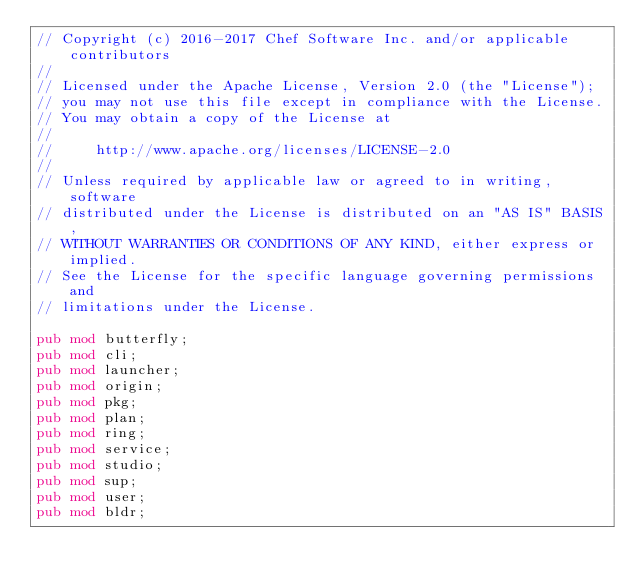Convert code to text. <code><loc_0><loc_0><loc_500><loc_500><_Rust_>// Copyright (c) 2016-2017 Chef Software Inc. and/or applicable contributors
//
// Licensed under the Apache License, Version 2.0 (the "License");
// you may not use this file except in compliance with the License.
// You may obtain a copy of the License at
//
//     http://www.apache.org/licenses/LICENSE-2.0
//
// Unless required by applicable law or agreed to in writing, software
// distributed under the License is distributed on an "AS IS" BASIS,
// WITHOUT WARRANTIES OR CONDITIONS OF ANY KIND, either express or implied.
// See the License for the specific language governing permissions and
// limitations under the License.

pub mod butterfly;
pub mod cli;
pub mod launcher;
pub mod origin;
pub mod pkg;
pub mod plan;
pub mod ring;
pub mod service;
pub mod studio;
pub mod sup;
pub mod user;
pub mod bldr;
</code> 